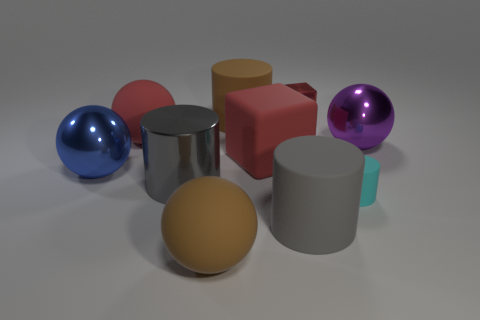Subtract all cyan cylinders. How many cylinders are left? 3 Subtract 3 cylinders. How many cylinders are left? 1 Add 5 tiny blocks. How many tiny blocks exist? 6 Subtract all brown cylinders. How many cylinders are left? 3 Subtract 2 gray cylinders. How many objects are left? 8 Subtract all cubes. How many objects are left? 8 Subtract all purple blocks. Subtract all green spheres. How many blocks are left? 2 Subtract all red balls. How many cyan cylinders are left? 1 Subtract all small red things. Subtract all yellow metallic things. How many objects are left? 9 Add 9 large brown matte balls. How many large brown matte balls are left? 10 